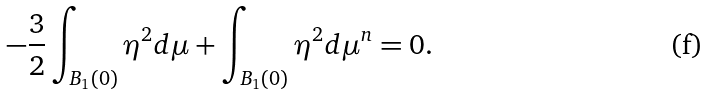Convert formula to latex. <formula><loc_0><loc_0><loc_500><loc_500>- \frac { 3 } { 2 } \int _ { B _ { 1 } ( 0 ) } \eta ^ { 2 } d \mu + \int _ { B _ { 1 } ( 0 ) } \eta ^ { 2 } d \mu ^ { n } = 0 .</formula> 